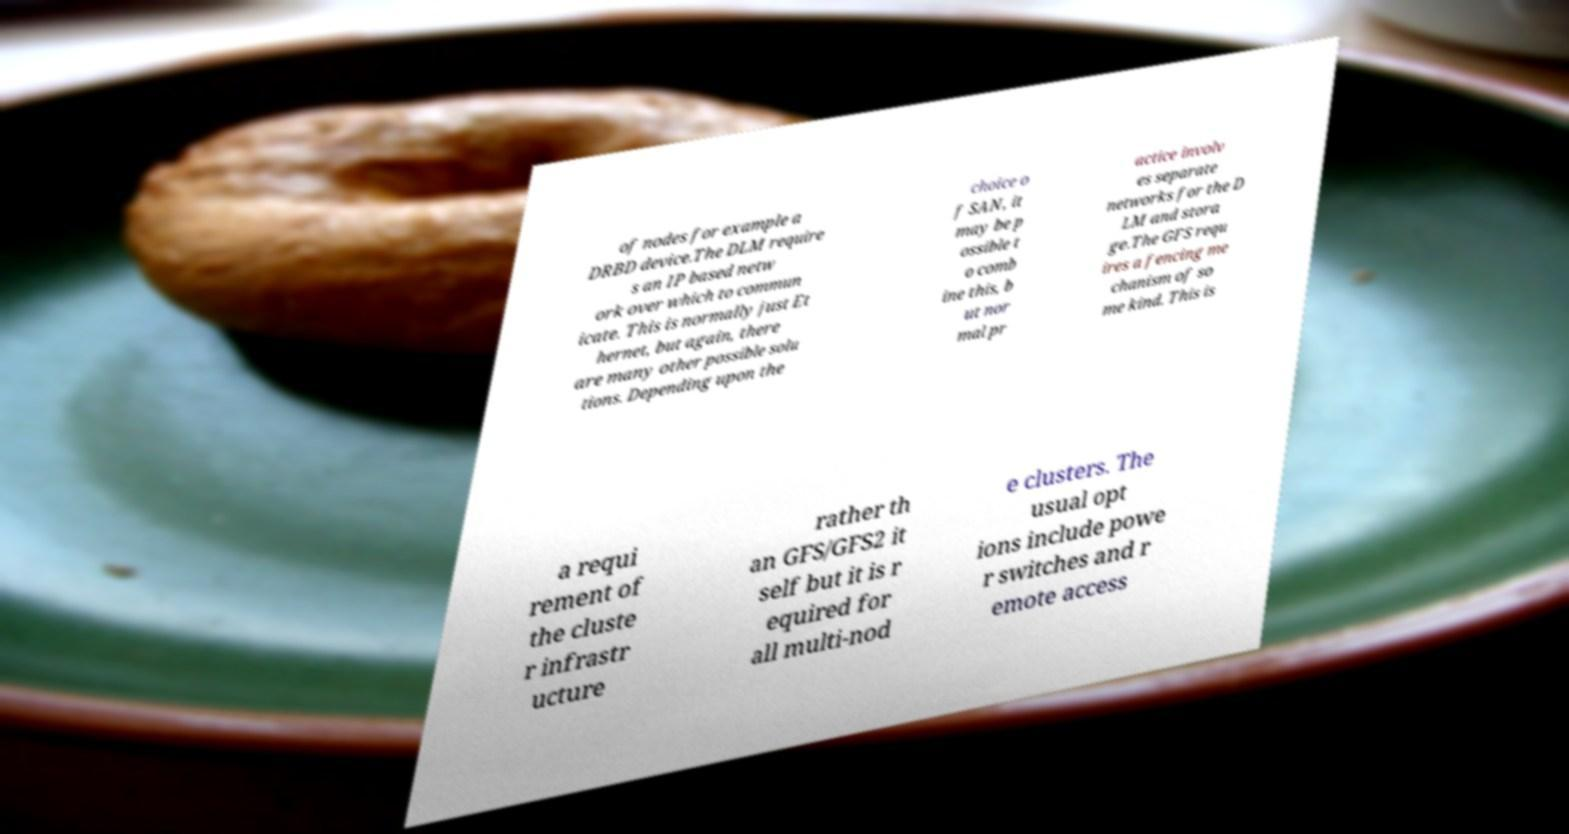For documentation purposes, I need the text within this image transcribed. Could you provide that? of nodes for example a DRBD device.The DLM require s an IP based netw ork over which to commun icate. This is normally just Et hernet, but again, there are many other possible solu tions. Depending upon the choice o f SAN, it may be p ossible t o comb ine this, b ut nor mal pr actice involv es separate networks for the D LM and stora ge.The GFS requ ires a fencing me chanism of so me kind. This is a requi rement of the cluste r infrastr ucture rather th an GFS/GFS2 it self but it is r equired for all multi-nod e clusters. The usual opt ions include powe r switches and r emote access 